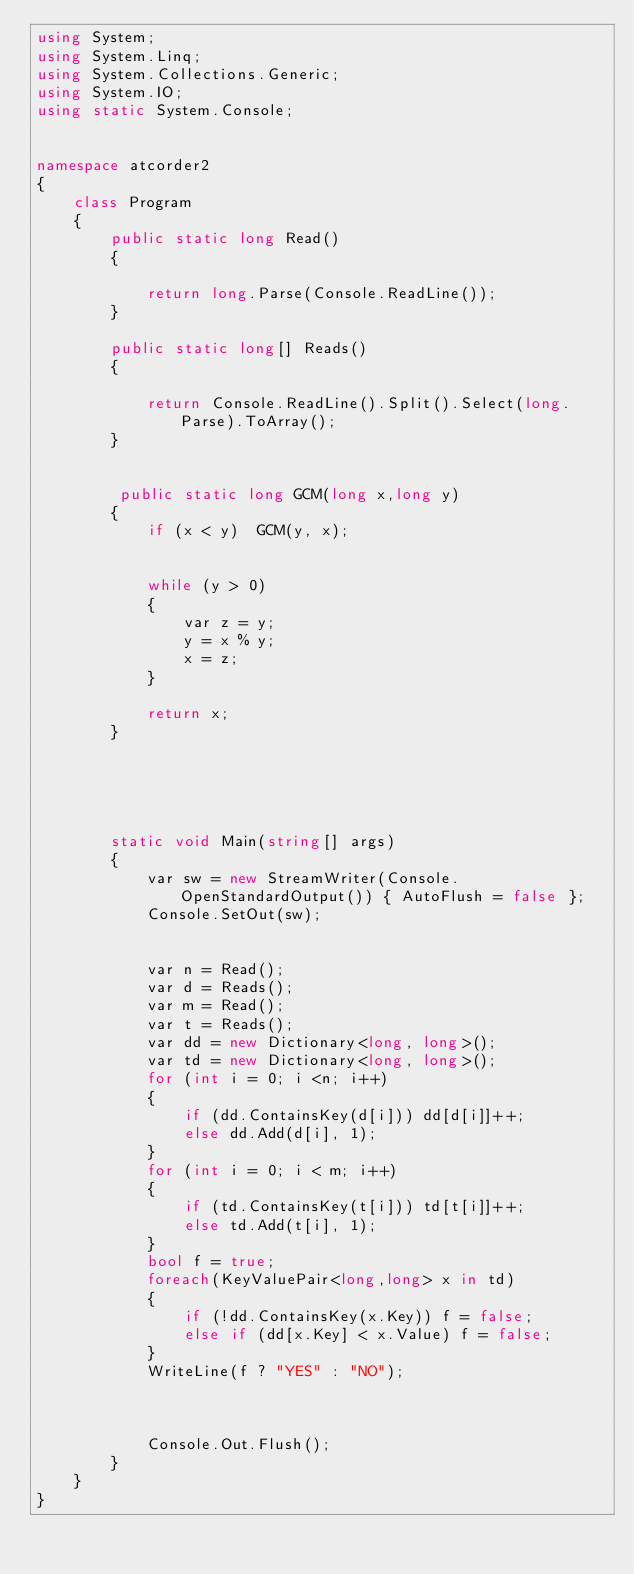<code> <loc_0><loc_0><loc_500><loc_500><_C#_>using System;
using System.Linq;
using System.Collections.Generic;
using System.IO;
using static System.Console;


namespace atcorder2
{
    class Program
    {
        public static long Read()
        {

            return long.Parse(Console.ReadLine());
        }

        public static long[] Reads()
        {

            return Console.ReadLine().Split().Select(long.Parse).ToArray();
        }

       
         public static long GCM(long x,long y)
        {
            if (x < y)  GCM(y, x);


            while (y > 0)
            {
                var z = y;
                y = x % y;
                x = z;
            }
            
            return x;
        }

        



        static void Main(string[] args)
        {
            var sw = new StreamWriter(Console.OpenStandardOutput()) { AutoFlush = false };
            Console.SetOut(sw);


            var n = Read();
            var d = Reads();
            var m = Read();
            var t = Reads();
            var dd = new Dictionary<long, long>();
            var td = new Dictionary<long, long>();
            for (int i = 0; i <n; i++)
            {
                if (dd.ContainsKey(d[i])) dd[d[i]]++;
                else dd.Add(d[i], 1);
            }
            for (int i = 0; i < m; i++)
            {
                if (td.ContainsKey(t[i])) td[t[i]]++;
                else td.Add(t[i], 1);
            }
            bool f = true;
            foreach(KeyValuePair<long,long> x in td)
            {
                if (!dd.ContainsKey(x.Key)) f = false;
                else if (dd[x.Key] < x.Value) f = false;
            }
            WriteLine(f ? "YES" : "NO");



            Console.Out.Flush();
        }
    }
}


</code> 